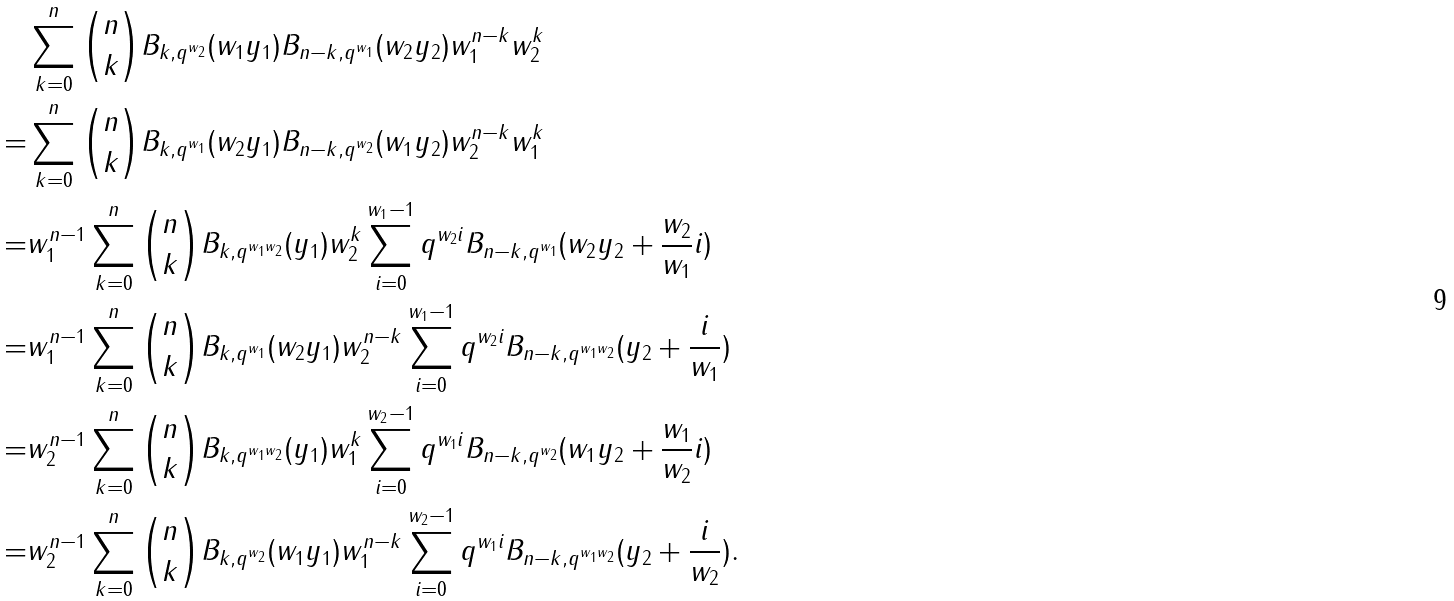Convert formula to latex. <formula><loc_0><loc_0><loc_500><loc_500>& \sum _ { k = 0 } ^ { n } \binom { n } { k } B _ { k , q ^ { w _ { 2 } } } ( w _ { 1 } y _ { 1 } ) B _ { n - k , q ^ { w _ { 1 } } } ( w _ { 2 } y _ { 2 } ) w _ { 1 } ^ { n - k } w _ { 2 } ^ { k } \\ = & \sum _ { k = 0 } ^ { n } \binom { n } { k } B _ { k , q ^ { w _ { 1 } } } ( w _ { 2 } y _ { 1 } ) B _ { n - k , q ^ { w _ { 2 } } } ( w _ { 1 } y _ { 2 } ) w _ { 2 } ^ { n - k } w _ { 1 } ^ { k } \\ = & w _ { 1 } ^ { n - 1 } \sum _ { k = 0 } ^ { n } \binom { n } { k } B _ { k , q ^ { w _ { 1 } w _ { 2 } } } ( y _ { 1 } ) w _ { 2 } ^ { k } \sum _ { i = 0 } ^ { w _ { 1 } - 1 } q ^ { w _ { 2 } i } B _ { n - k , q ^ { w _ { 1 } } } ( w _ { 2 } y _ { 2 } + \frac { w _ { 2 } } { w _ { 1 } } i ) \\ = & w _ { 1 } ^ { n - 1 } \sum _ { k = 0 } ^ { n } \binom { n } { k } B _ { k , q ^ { w _ { 1 } } } ( w _ { 2 } y _ { 1 } ) w _ { 2 } ^ { n - k } \sum _ { i = 0 } ^ { w _ { 1 } - 1 } q ^ { w _ { 2 } i } B _ { n - k , q ^ { w _ { 1 } w _ { 2 } } } ( y _ { 2 } + \frac { i } { w _ { 1 } } ) \\ = & w _ { 2 } ^ { n - 1 } \sum _ { k = 0 } ^ { n } \binom { n } { k } B _ { k , q ^ { w _ { 1 } w _ { 2 } } } ( y _ { 1 } ) w _ { 1 } ^ { k } \sum _ { i = 0 } ^ { w _ { 2 } - 1 } q ^ { w _ { 1 } i } B _ { n - k , q ^ { w _ { 2 } } } ( w _ { 1 } y _ { 2 } + \frac { w _ { 1 } } { w _ { 2 } } i ) \\ = & w _ { 2 } ^ { n - 1 } \sum _ { k = 0 } ^ { n } \binom { n } { k } B _ { k , q ^ { w _ { 2 } } } ( w _ { 1 } y _ { 1 } ) w _ { 1 } ^ { n - k } \sum _ { i = 0 } ^ { w _ { 2 } - 1 } q ^ { w _ { 1 } i } B _ { n - k , q ^ { w _ { 1 } w _ { 2 } } } ( y _ { 2 } + \frac { i } { w _ { 2 } } ) .</formula> 